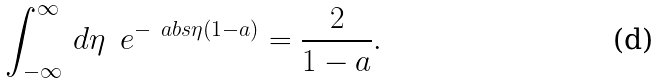Convert formula to latex. <formula><loc_0><loc_0><loc_500><loc_500>\int _ { - \infty } ^ { \infty } \, d \eta \, \ e ^ { - \ a b s { \eta } ( 1 - a ) } = \frac { 2 } { 1 - a } .</formula> 